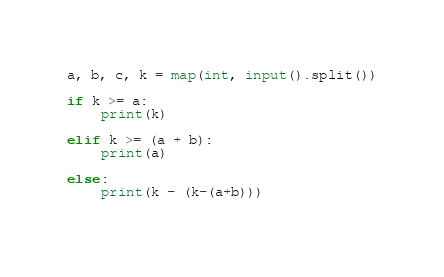Convert code to text. <code><loc_0><loc_0><loc_500><loc_500><_Python_>a, b, c, k = map(int, input().split())

if k >= a:
    print(k)

elif k >= (a + b):
    print(a)

else:
    print(k - (k-(a+b)))
    </code> 